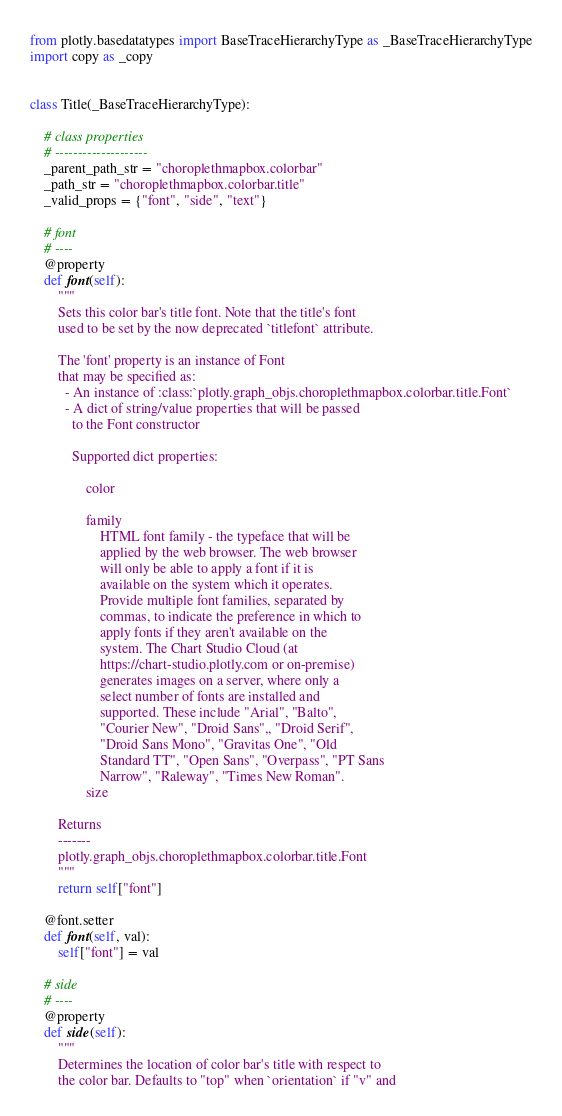<code> <loc_0><loc_0><loc_500><loc_500><_Python_>from plotly.basedatatypes import BaseTraceHierarchyType as _BaseTraceHierarchyType
import copy as _copy


class Title(_BaseTraceHierarchyType):

    # class properties
    # --------------------
    _parent_path_str = "choroplethmapbox.colorbar"
    _path_str = "choroplethmapbox.colorbar.title"
    _valid_props = {"font", "side", "text"}

    # font
    # ----
    @property
    def font(self):
        """
        Sets this color bar's title font. Note that the title's font
        used to be set by the now deprecated `titlefont` attribute.
    
        The 'font' property is an instance of Font
        that may be specified as:
          - An instance of :class:`plotly.graph_objs.choroplethmapbox.colorbar.title.Font`
          - A dict of string/value properties that will be passed
            to the Font constructor
    
            Supported dict properties:
                
                color
    
                family
                    HTML font family - the typeface that will be
                    applied by the web browser. The web browser
                    will only be able to apply a font if it is
                    available on the system which it operates.
                    Provide multiple font families, separated by
                    commas, to indicate the preference in which to
                    apply fonts if they aren't available on the
                    system. The Chart Studio Cloud (at
                    https://chart-studio.plotly.com or on-premise)
                    generates images on a server, where only a
                    select number of fonts are installed and
                    supported. These include "Arial", "Balto",
                    "Courier New", "Droid Sans",, "Droid Serif",
                    "Droid Sans Mono", "Gravitas One", "Old
                    Standard TT", "Open Sans", "Overpass", "PT Sans
                    Narrow", "Raleway", "Times New Roman".
                size

        Returns
        -------
        plotly.graph_objs.choroplethmapbox.colorbar.title.Font
        """
        return self["font"]

    @font.setter
    def font(self, val):
        self["font"] = val

    # side
    # ----
    @property
    def side(self):
        """
        Determines the location of color bar's title with respect to
        the color bar. Defaults to "top" when `orientation` if "v" and</code> 